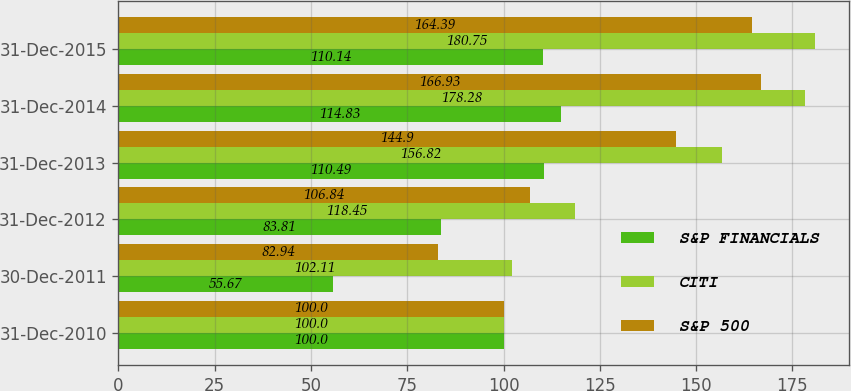<chart> <loc_0><loc_0><loc_500><loc_500><stacked_bar_chart><ecel><fcel>31-Dec-2010<fcel>30-Dec-2011<fcel>31-Dec-2012<fcel>31-Dec-2013<fcel>31-Dec-2014<fcel>31-Dec-2015<nl><fcel>S&P FINANCIALS<fcel>100<fcel>55.67<fcel>83.81<fcel>110.49<fcel>114.83<fcel>110.14<nl><fcel>CITI<fcel>100<fcel>102.11<fcel>118.45<fcel>156.82<fcel>178.28<fcel>180.75<nl><fcel>S&P 500<fcel>100<fcel>82.94<fcel>106.84<fcel>144.9<fcel>166.93<fcel>164.39<nl></chart> 